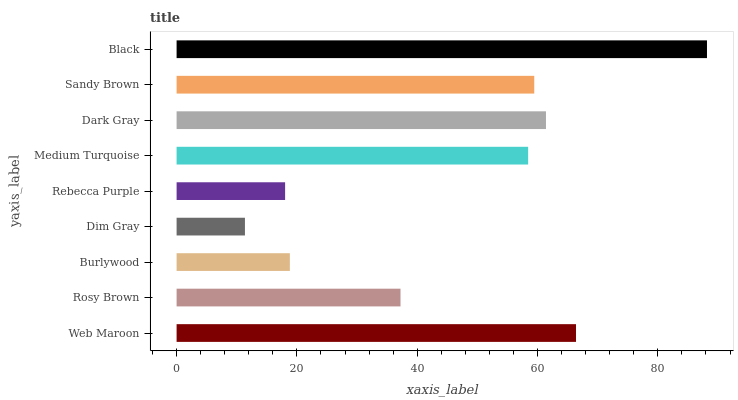Is Dim Gray the minimum?
Answer yes or no. Yes. Is Black the maximum?
Answer yes or no. Yes. Is Rosy Brown the minimum?
Answer yes or no. No. Is Rosy Brown the maximum?
Answer yes or no. No. Is Web Maroon greater than Rosy Brown?
Answer yes or no. Yes. Is Rosy Brown less than Web Maroon?
Answer yes or no. Yes. Is Rosy Brown greater than Web Maroon?
Answer yes or no. No. Is Web Maroon less than Rosy Brown?
Answer yes or no. No. Is Medium Turquoise the high median?
Answer yes or no. Yes. Is Medium Turquoise the low median?
Answer yes or no. Yes. Is Rosy Brown the high median?
Answer yes or no. No. Is Black the low median?
Answer yes or no. No. 